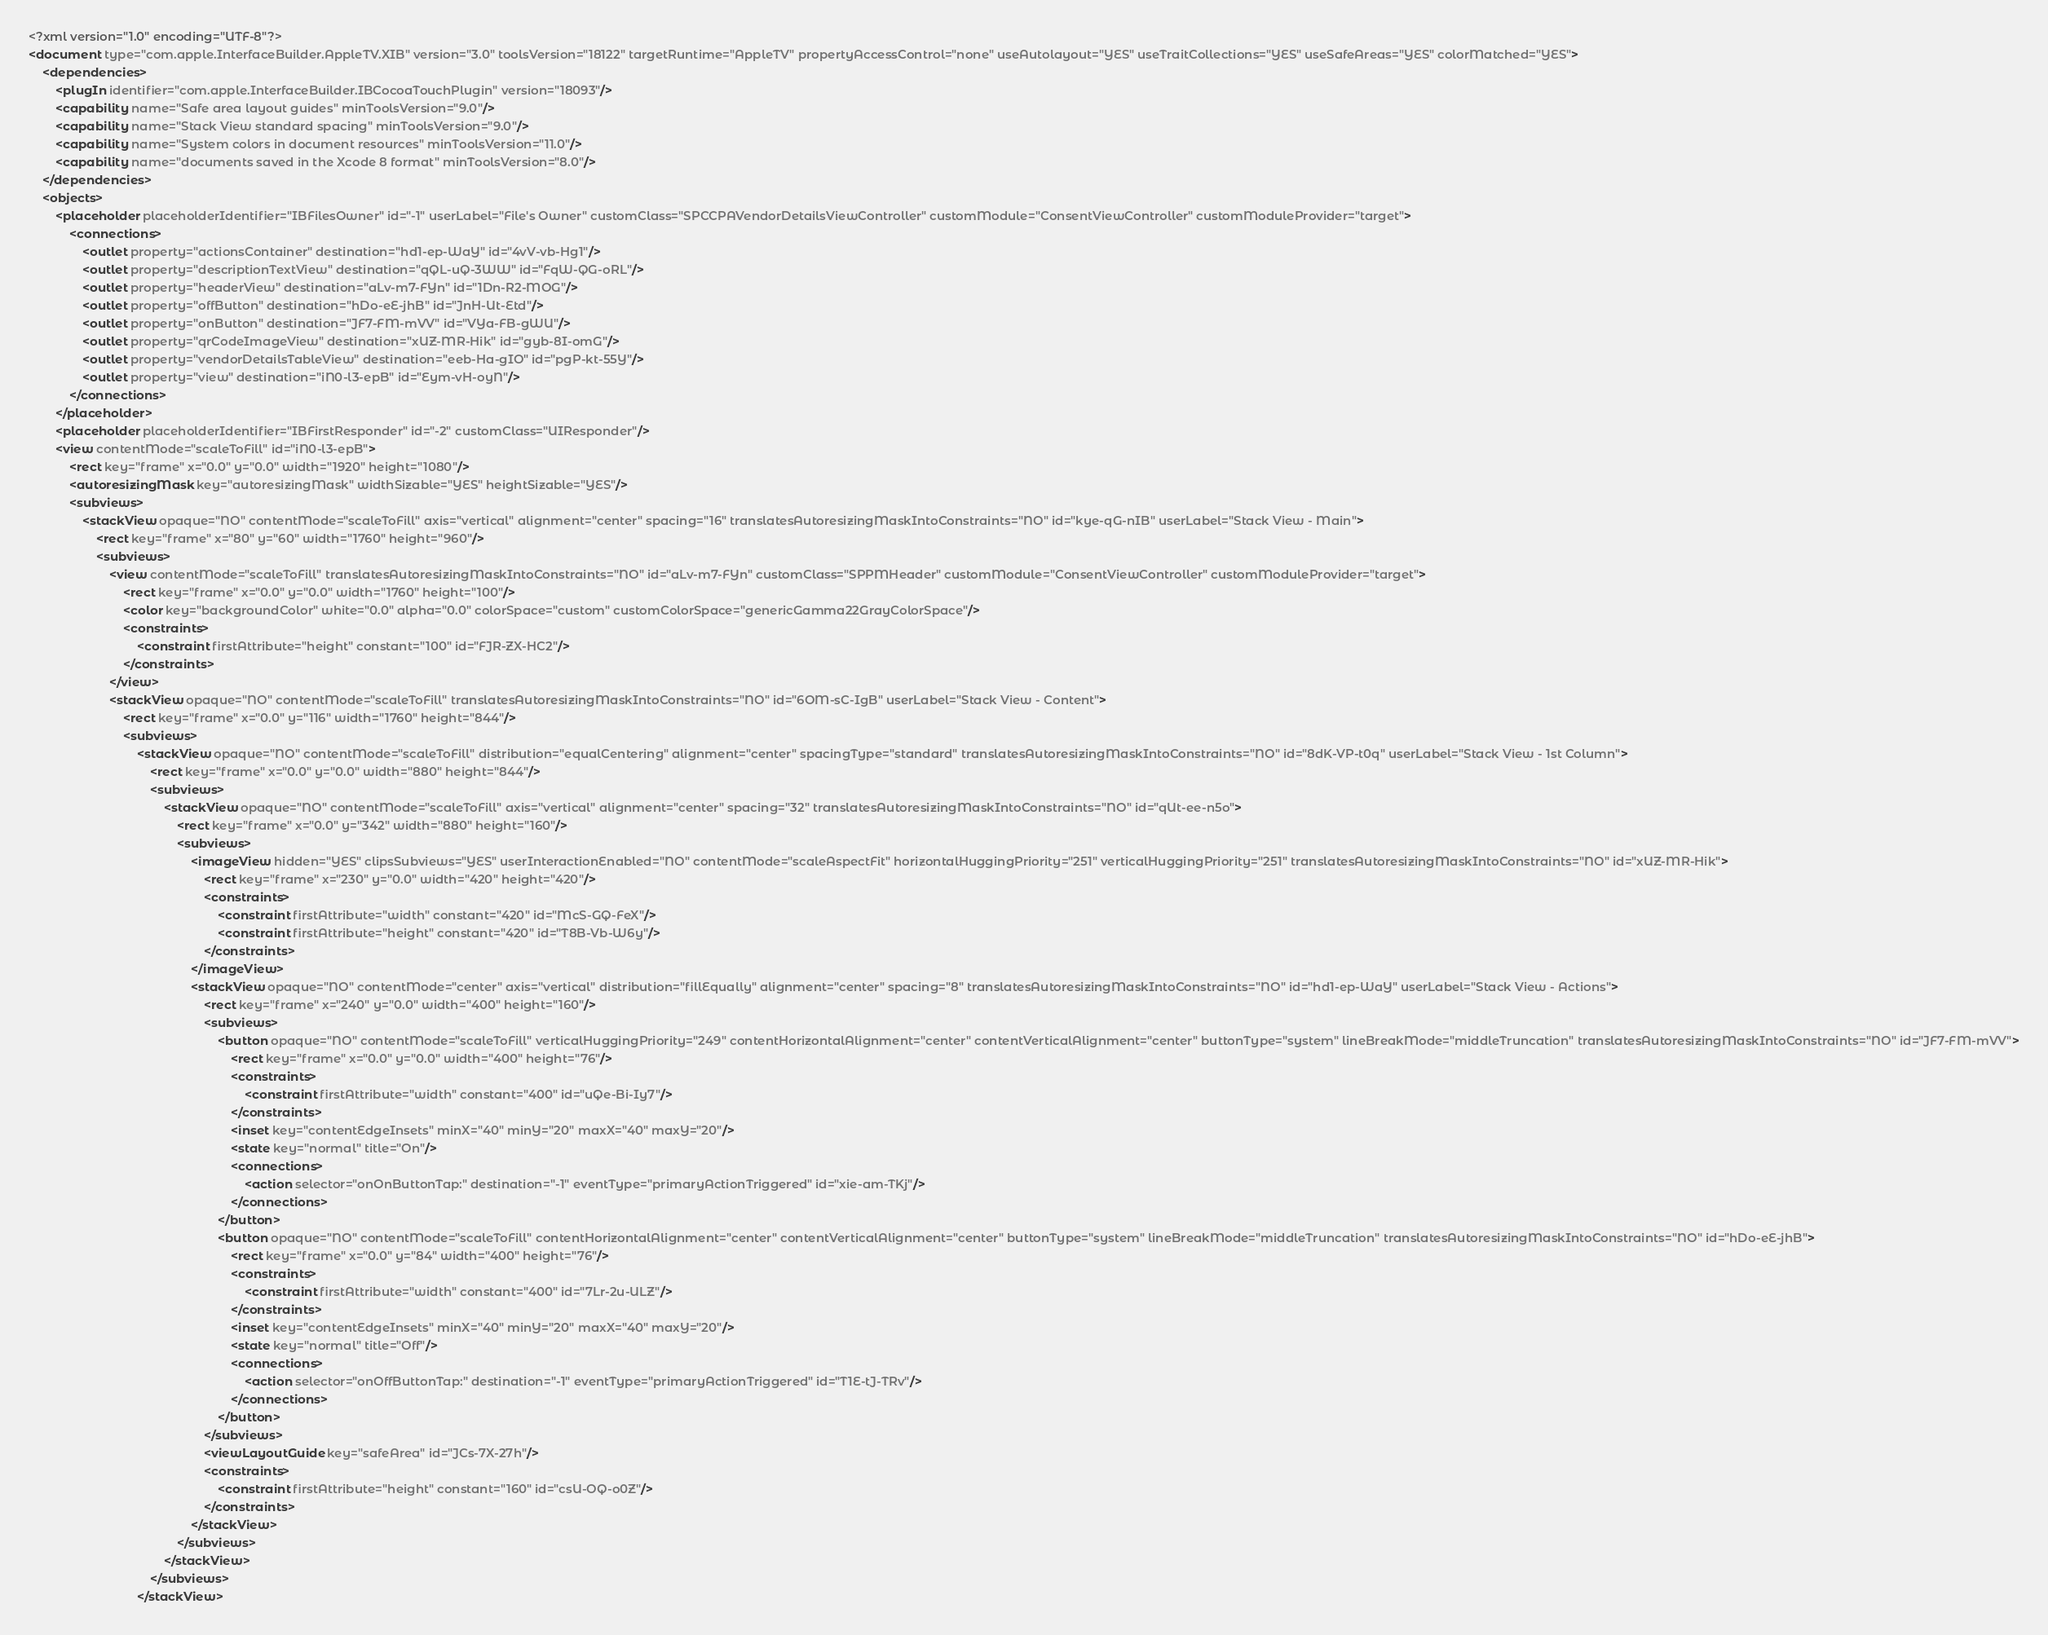Convert code to text. <code><loc_0><loc_0><loc_500><loc_500><_XML_><?xml version="1.0" encoding="UTF-8"?>
<document type="com.apple.InterfaceBuilder.AppleTV.XIB" version="3.0" toolsVersion="18122" targetRuntime="AppleTV" propertyAccessControl="none" useAutolayout="YES" useTraitCollections="YES" useSafeAreas="YES" colorMatched="YES">
    <dependencies>
        <plugIn identifier="com.apple.InterfaceBuilder.IBCocoaTouchPlugin" version="18093"/>
        <capability name="Safe area layout guides" minToolsVersion="9.0"/>
        <capability name="Stack View standard spacing" minToolsVersion="9.0"/>
        <capability name="System colors in document resources" minToolsVersion="11.0"/>
        <capability name="documents saved in the Xcode 8 format" minToolsVersion="8.0"/>
    </dependencies>
    <objects>
        <placeholder placeholderIdentifier="IBFilesOwner" id="-1" userLabel="File's Owner" customClass="SPCCPAVendorDetailsViewController" customModule="ConsentViewController" customModuleProvider="target">
            <connections>
                <outlet property="actionsContainer" destination="hd1-ep-WaY" id="4vV-vb-Hg1"/>
                <outlet property="descriptionTextView" destination="qQL-uQ-3WW" id="FqW-QG-oRL"/>
                <outlet property="headerView" destination="aLv-m7-FYn" id="1Dn-R2-MOG"/>
                <outlet property="offButton" destination="hDo-eE-jhB" id="JnH-Ut-Etd"/>
                <outlet property="onButton" destination="JF7-FM-mVV" id="VYa-FB-gWU"/>
                <outlet property="qrCodeImageView" destination="xUZ-MR-Hik" id="gyb-8I-omG"/>
                <outlet property="vendorDetailsTableView" destination="eeb-Ha-gIO" id="pgP-kt-55Y"/>
                <outlet property="view" destination="iN0-l3-epB" id="Eym-vH-oyN"/>
            </connections>
        </placeholder>
        <placeholder placeholderIdentifier="IBFirstResponder" id="-2" customClass="UIResponder"/>
        <view contentMode="scaleToFill" id="iN0-l3-epB">
            <rect key="frame" x="0.0" y="0.0" width="1920" height="1080"/>
            <autoresizingMask key="autoresizingMask" widthSizable="YES" heightSizable="YES"/>
            <subviews>
                <stackView opaque="NO" contentMode="scaleToFill" axis="vertical" alignment="center" spacing="16" translatesAutoresizingMaskIntoConstraints="NO" id="kye-qG-nIB" userLabel="Stack View - Main">
                    <rect key="frame" x="80" y="60" width="1760" height="960"/>
                    <subviews>
                        <view contentMode="scaleToFill" translatesAutoresizingMaskIntoConstraints="NO" id="aLv-m7-FYn" customClass="SPPMHeader" customModule="ConsentViewController" customModuleProvider="target">
                            <rect key="frame" x="0.0" y="0.0" width="1760" height="100"/>
                            <color key="backgroundColor" white="0.0" alpha="0.0" colorSpace="custom" customColorSpace="genericGamma22GrayColorSpace"/>
                            <constraints>
                                <constraint firstAttribute="height" constant="100" id="FJR-ZX-HC2"/>
                            </constraints>
                        </view>
                        <stackView opaque="NO" contentMode="scaleToFill" translatesAutoresizingMaskIntoConstraints="NO" id="6OM-sC-IgB" userLabel="Stack View - Content">
                            <rect key="frame" x="0.0" y="116" width="1760" height="844"/>
                            <subviews>
                                <stackView opaque="NO" contentMode="scaleToFill" distribution="equalCentering" alignment="center" spacingType="standard" translatesAutoresizingMaskIntoConstraints="NO" id="8dK-VP-t0q" userLabel="Stack View - 1st Column">
                                    <rect key="frame" x="0.0" y="0.0" width="880" height="844"/>
                                    <subviews>
                                        <stackView opaque="NO" contentMode="scaleToFill" axis="vertical" alignment="center" spacing="32" translatesAutoresizingMaskIntoConstraints="NO" id="qUt-ee-n5o">
                                            <rect key="frame" x="0.0" y="342" width="880" height="160"/>
                                            <subviews>
                                                <imageView hidden="YES" clipsSubviews="YES" userInteractionEnabled="NO" contentMode="scaleAspectFit" horizontalHuggingPriority="251" verticalHuggingPriority="251" translatesAutoresizingMaskIntoConstraints="NO" id="xUZ-MR-Hik">
                                                    <rect key="frame" x="230" y="0.0" width="420" height="420"/>
                                                    <constraints>
                                                        <constraint firstAttribute="width" constant="420" id="McS-GQ-FeX"/>
                                                        <constraint firstAttribute="height" constant="420" id="T8B-Vb-W6y"/>
                                                    </constraints>
                                                </imageView>
                                                <stackView opaque="NO" contentMode="center" axis="vertical" distribution="fillEqually" alignment="center" spacing="8" translatesAutoresizingMaskIntoConstraints="NO" id="hd1-ep-WaY" userLabel="Stack View - Actions">
                                                    <rect key="frame" x="240" y="0.0" width="400" height="160"/>
                                                    <subviews>
                                                        <button opaque="NO" contentMode="scaleToFill" verticalHuggingPriority="249" contentHorizontalAlignment="center" contentVerticalAlignment="center" buttonType="system" lineBreakMode="middleTruncation" translatesAutoresizingMaskIntoConstraints="NO" id="JF7-FM-mVV">
                                                            <rect key="frame" x="0.0" y="0.0" width="400" height="76"/>
                                                            <constraints>
                                                                <constraint firstAttribute="width" constant="400" id="uQe-Bi-Iy7"/>
                                                            </constraints>
                                                            <inset key="contentEdgeInsets" minX="40" minY="20" maxX="40" maxY="20"/>
                                                            <state key="normal" title="On"/>
                                                            <connections>
                                                                <action selector="onOnButtonTap:" destination="-1" eventType="primaryActionTriggered" id="xie-am-TKj"/>
                                                            </connections>
                                                        </button>
                                                        <button opaque="NO" contentMode="scaleToFill" contentHorizontalAlignment="center" contentVerticalAlignment="center" buttonType="system" lineBreakMode="middleTruncation" translatesAutoresizingMaskIntoConstraints="NO" id="hDo-eE-jhB">
                                                            <rect key="frame" x="0.0" y="84" width="400" height="76"/>
                                                            <constraints>
                                                                <constraint firstAttribute="width" constant="400" id="7Lr-2u-ULZ"/>
                                                            </constraints>
                                                            <inset key="contentEdgeInsets" minX="40" minY="20" maxX="40" maxY="20"/>
                                                            <state key="normal" title="Off"/>
                                                            <connections>
                                                                <action selector="onOffButtonTap:" destination="-1" eventType="primaryActionTriggered" id="T1E-tJ-TRv"/>
                                                            </connections>
                                                        </button>
                                                    </subviews>
                                                    <viewLayoutGuide key="safeArea" id="JCs-7X-27h"/>
                                                    <constraints>
                                                        <constraint firstAttribute="height" constant="160" id="csU-OQ-o0Z"/>
                                                    </constraints>
                                                </stackView>
                                            </subviews>
                                        </stackView>
                                    </subviews>
                                </stackView></code> 